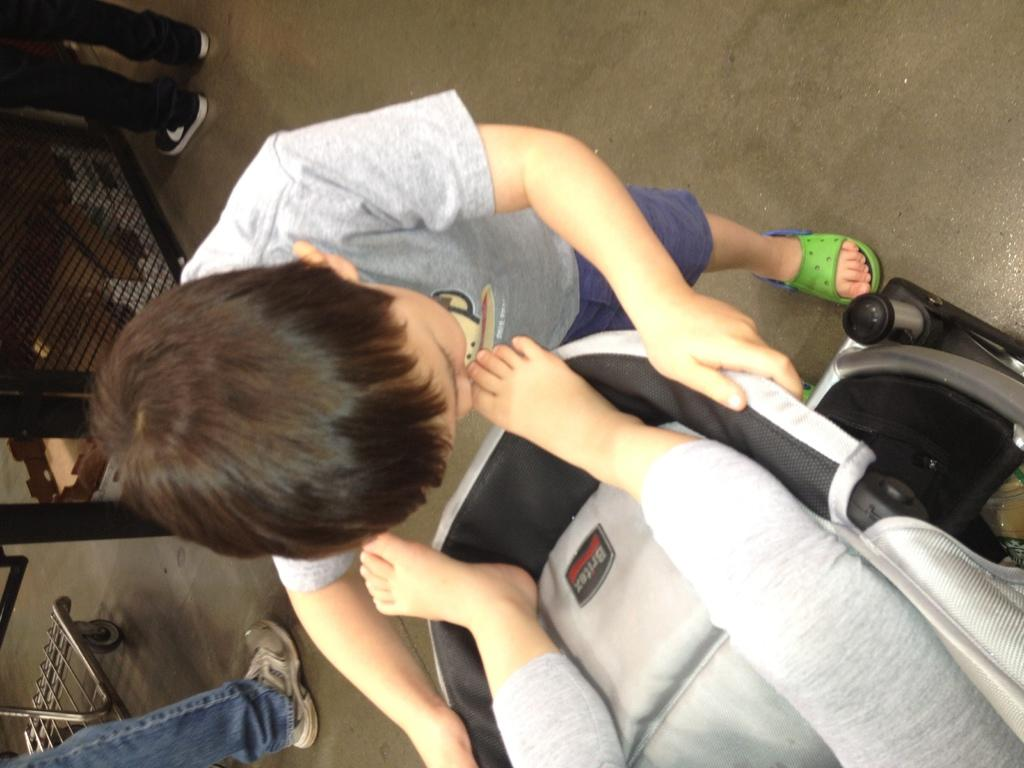What is the main subject of the image? There is a person on a trolley in the image. Can you describe the surroundings of the person on the trolley? There are people visible in the background of the image, and there is another trolley and a mesh in the background as well. What is visible at the bottom of the image? There is a road visible at the bottom of the image. What type of eggnog is being served on the trolley in the image? There is no eggnog present in the image; it features a person on a trolley with a background containing people, another trolley, a mesh, and a road. What thought is the ant having while observing the person on the trolley in the image? There is no ant present in the image, so it is not possible to determine any thoughts it might have. 